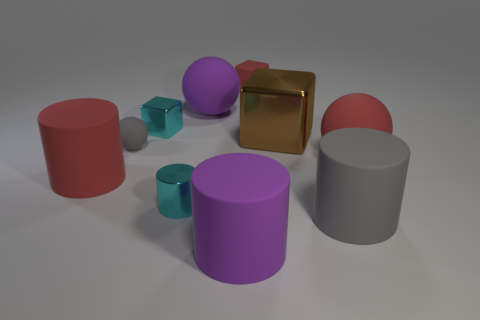Can you guess the approximate size of the purple cylinder in the middle? While exact measurements can't be provided without a reference, the purple cylinder in the middle seems to be roughly twice as tall as the nearby red sphere, suggesting it might be of a considerable size relative to the other objects. 